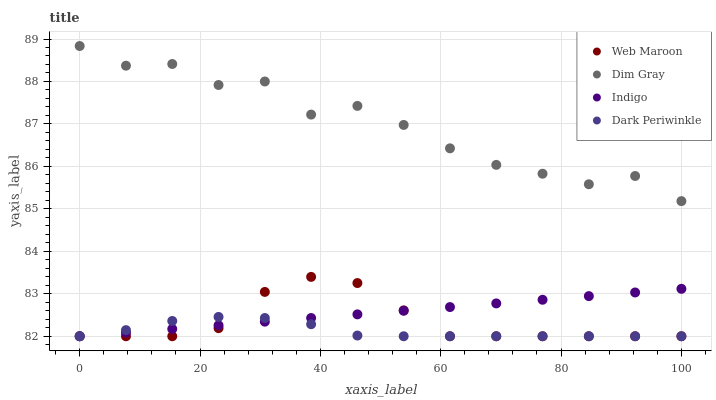Does Dark Periwinkle have the minimum area under the curve?
Answer yes or no. Yes. Does Dim Gray have the maximum area under the curve?
Answer yes or no. Yes. Does Web Maroon have the minimum area under the curve?
Answer yes or no. No. Does Web Maroon have the maximum area under the curve?
Answer yes or no. No. Is Indigo the smoothest?
Answer yes or no. Yes. Is Dim Gray the roughest?
Answer yes or no. Yes. Is Web Maroon the smoothest?
Answer yes or no. No. Is Web Maroon the roughest?
Answer yes or no. No. Does Indigo have the lowest value?
Answer yes or no. Yes. Does Dim Gray have the lowest value?
Answer yes or no. No. Does Dim Gray have the highest value?
Answer yes or no. Yes. Does Web Maroon have the highest value?
Answer yes or no. No. Is Indigo less than Dim Gray?
Answer yes or no. Yes. Is Dim Gray greater than Web Maroon?
Answer yes or no. Yes. Does Web Maroon intersect Indigo?
Answer yes or no. Yes. Is Web Maroon less than Indigo?
Answer yes or no. No. Is Web Maroon greater than Indigo?
Answer yes or no. No. Does Indigo intersect Dim Gray?
Answer yes or no. No. 